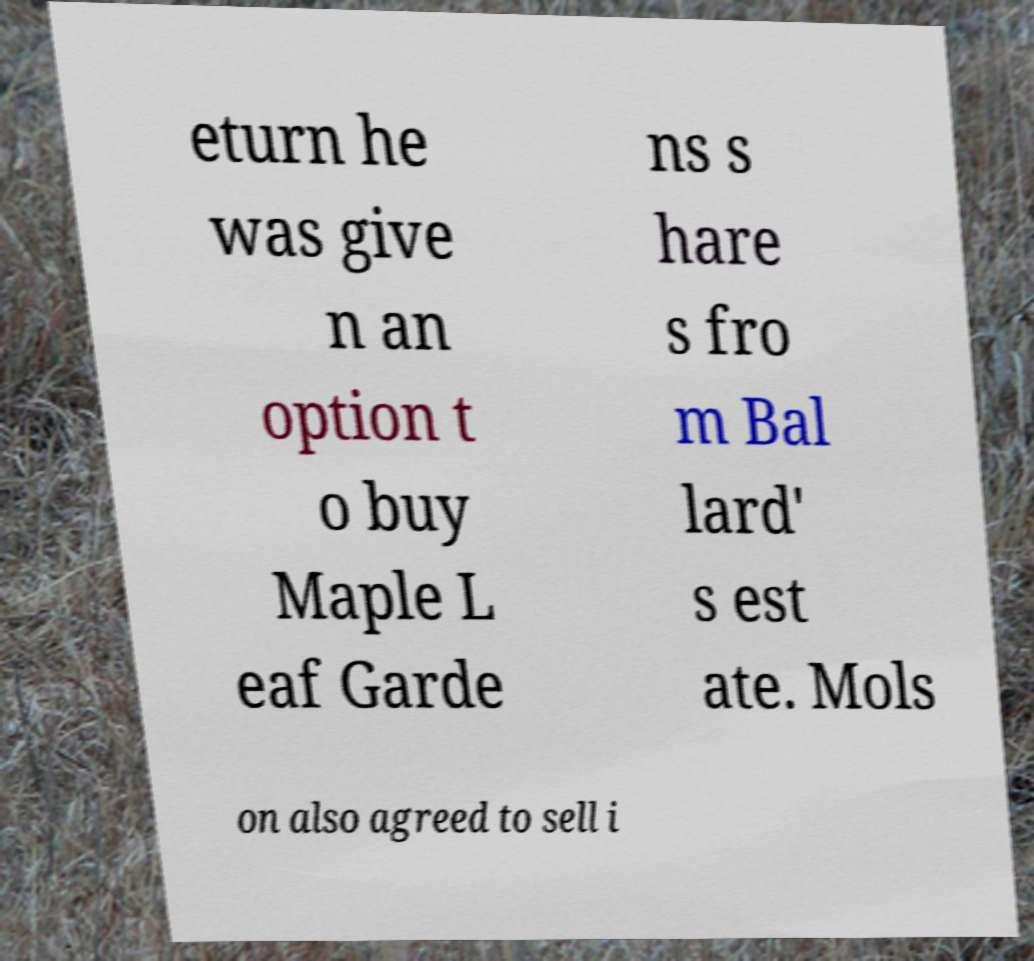Please identify and transcribe the text found in this image. eturn he was give n an option t o buy Maple L eaf Garde ns s hare s fro m Bal lard' s est ate. Mols on also agreed to sell i 